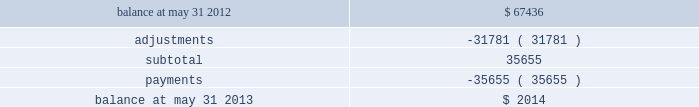Our initial estimate of fraud losses , fines and other charges on our understanding of the rules and operating regulations published by the networks and preliminary communications with the networks .
We have now reached resolution with and made payments to the networks , resulting in charges that were less than our initial estimates .
The primary difference between our initial estimates and the final charges relates to lower fraud related costs attributed to this event than previously expected .
The table reflects the activity in our accrual for fraud losses , fines and other charges for the twelve months ended may 31 , 2013 ( in thousands ) : .
We were insured under policies that provided coverage of certain costs associated with this event .
The policies provided a total of $ 30.0 million in policy limits and contained various sub-limits of liability and other terms , conditions and limitations , including a $ 1.0 million deductible per claim .
As of fiscal year 2013 , we received assessments from certain networks and submitted additional claims to the insurers and recorded $ 20.0 million in additional insurance recoveries based on our negotiations with our insurers .
We will record receivables for any additional recoveries in the periods in which we determine such recovery is probable and the amount can be reasonably estimated .
A class action arising out of the processing system intrusion was filed against us on april 4 , 2012 by natalie willingham ( individually and on behalf of a putative nationwide class ) ( the 201cplaintiff 201d ) .
Specifically , ms .
Willingham alleged that we failed to maintain reasonable and adequate procedures to protect her personally identifiable information ( 201cpii 201d ) which she claims resulted in two fraudulent charges on her credit card in march 2012 .
Further , ms .
Willingham asserted that we failed to timely notify the public of the data breach .
Based on these allegations , ms .
Willingham asserted claims for negligence , violation of the federal stored communications act , willful violation of the fair credit reporting act , negligent violation of the fair credit reporting act , violation of georgia 2019s unfair and deceptive trade practices act , negligence per se , breach of third-party beneficiary contract , and breach of implied contract .
Ms .
Willingham sought an unspecified amount of damages and injunctive relief .
The lawsuit was filed in the united states district court for the northern district of georgia .
On may 14 , 2012 , we filed a motion to dismiss .
On july 11 , 2012 , plaintiff filed a motion for leave to amend her complaint , and on july 16 , 2012 , the court granted that motion .
She then filed an amended complaint on july 16 , 2012 .
The amended complaint did not add any new causes of action .
Instead , it added two new named plaintiffs ( nadine and robert hielscher ) ( together with plaintiff , the 201cplaintiffs 201d ) and dropped plaintiff 2019s claim for negligence per se .
On august 16 , 2012 , we filed a motion to dismiss the plaintiffs 2019 amended complaint .
The plaintiffs filed their response in opposition to our motion to dismiss on october 5 , 2012 , and we subsequently filed our reply brief on october 22 , 2012 .
The magistrate judge issued a report and recommendation recommending dismissal of all of plaintiffs 2019 claims with prejudice .
The plaintiffs subsequently agreed to voluntarily dismiss the lawsuit with prejudice , with each party bearing its own fees and costs .
This was the only consideration exchanged by the parties in connection with plaintiffs 2019 voluntary dismissal with prejudice of the lawsuit .
The lawsuit was dismissed with prejudice on march 6 , 2013 .
Note 3 2014settlement processing assets and obligations we are designated as a merchant service provider by mastercard and an independent sales organization by visa .
These designations are dependent upon member clearing banks ( 201cmember 201d ) sponsoring us and our adherence to the standards of the networks .
We have primary financial institution sponsors in the various markets where we facilitate payment transactions with whom we have sponsorship or depository and clearing agreements .
These agreements allow us to route transactions under the member banks 2019 control and identification numbers to clear credit card transactions through mastercard and visa .
In certain markets , we are members in various payment networks , allowing us to process and fund transactions without third-party sponsorship. .
What portion of the beginning balance of accrual for fraud losses is paid in cash? 
Computations: (35655 / 67436)
Answer: 0.52872. Our initial estimate of fraud losses , fines and other charges on our understanding of the rules and operating regulations published by the networks and preliminary communications with the networks .
We have now reached resolution with and made payments to the networks , resulting in charges that were less than our initial estimates .
The primary difference between our initial estimates and the final charges relates to lower fraud related costs attributed to this event than previously expected .
The table reflects the activity in our accrual for fraud losses , fines and other charges for the twelve months ended may 31 , 2013 ( in thousands ) : .
We were insured under policies that provided coverage of certain costs associated with this event .
The policies provided a total of $ 30.0 million in policy limits and contained various sub-limits of liability and other terms , conditions and limitations , including a $ 1.0 million deductible per claim .
As of fiscal year 2013 , we received assessments from certain networks and submitted additional claims to the insurers and recorded $ 20.0 million in additional insurance recoveries based on our negotiations with our insurers .
We will record receivables for any additional recoveries in the periods in which we determine such recovery is probable and the amount can be reasonably estimated .
A class action arising out of the processing system intrusion was filed against us on april 4 , 2012 by natalie willingham ( individually and on behalf of a putative nationwide class ) ( the 201cplaintiff 201d ) .
Specifically , ms .
Willingham alleged that we failed to maintain reasonable and adequate procedures to protect her personally identifiable information ( 201cpii 201d ) which she claims resulted in two fraudulent charges on her credit card in march 2012 .
Further , ms .
Willingham asserted that we failed to timely notify the public of the data breach .
Based on these allegations , ms .
Willingham asserted claims for negligence , violation of the federal stored communications act , willful violation of the fair credit reporting act , negligent violation of the fair credit reporting act , violation of georgia 2019s unfair and deceptive trade practices act , negligence per se , breach of third-party beneficiary contract , and breach of implied contract .
Ms .
Willingham sought an unspecified amount of damages and injunctive relief .
The lawsuit was filed in the united states district court for the northern district of georgia .
On may 14 , 2012 , we filed a motion to dismiss .
On july 11 , 2012 , plaintiff filed a motion for leave to amend her complaint , and on july 16 , 2012 , the court granted that motion .
She then filed an amended complaint on july 16 , 2012 .
The amended complaint did not add any new causes of action .
Instead , it added two new named plaintiffs ( nadine and robert hielscher ) ( together with plaintiff , the 201cplaintiffs 201d ) and dropped plaintiff 2019s claim for negligence per se .
On august 16 , 2012 , we filed a motion to dismiss the plaintiffs 2019 amended complaint .
The plaintiffs filed their response in opposition to our motion to dismiss on october 5 , 2012 , and we subsequently filed our reply brief on october 22 , 2012 .
The magistrate judge issued a report and recommendation recommending dismissal of all of plaintiffs 2019 claims with prejudice .
The plaintiffs subsequently agreed to voluntarily dismiss the lawsuit with prejudice , with each party bearing its own fees and costs .
This was the only consideration exchanged by the parties in connection with plaintiffs 2019 voluntary dismissal with prejudice of the lawsuit .
The lawsuit was dismissed with prejudice on march 6 , 2013 .
Note 3 2014settlement processing assets and obligations we are designated as a merchant service provider by mastercard and an independent sales organization by visa .
These designations are dependent upon member clearing banks ( 201cmember 201d ) sponsoring us and our adherence to the standards of the networks .
We have primary financial institution sponsors in the various markets where we facilitate payment transactions with whom we have sponsorship or depository and clearing agreements .
These agreements allow us to route transactions under the member banks 2019 control and identification numbers to clear credit card transactions through mastercard and visa .
In certain markets , we are members in various payment networks , allowing us to process and fund transactions without third-party sponsorship. .
What percent of the balance was used on payments .? 
Rationale: to figure out the percentage payments are , one must divide payments by the balance .
Computations: (35655 / 67436)
Answer: 0.52872. 